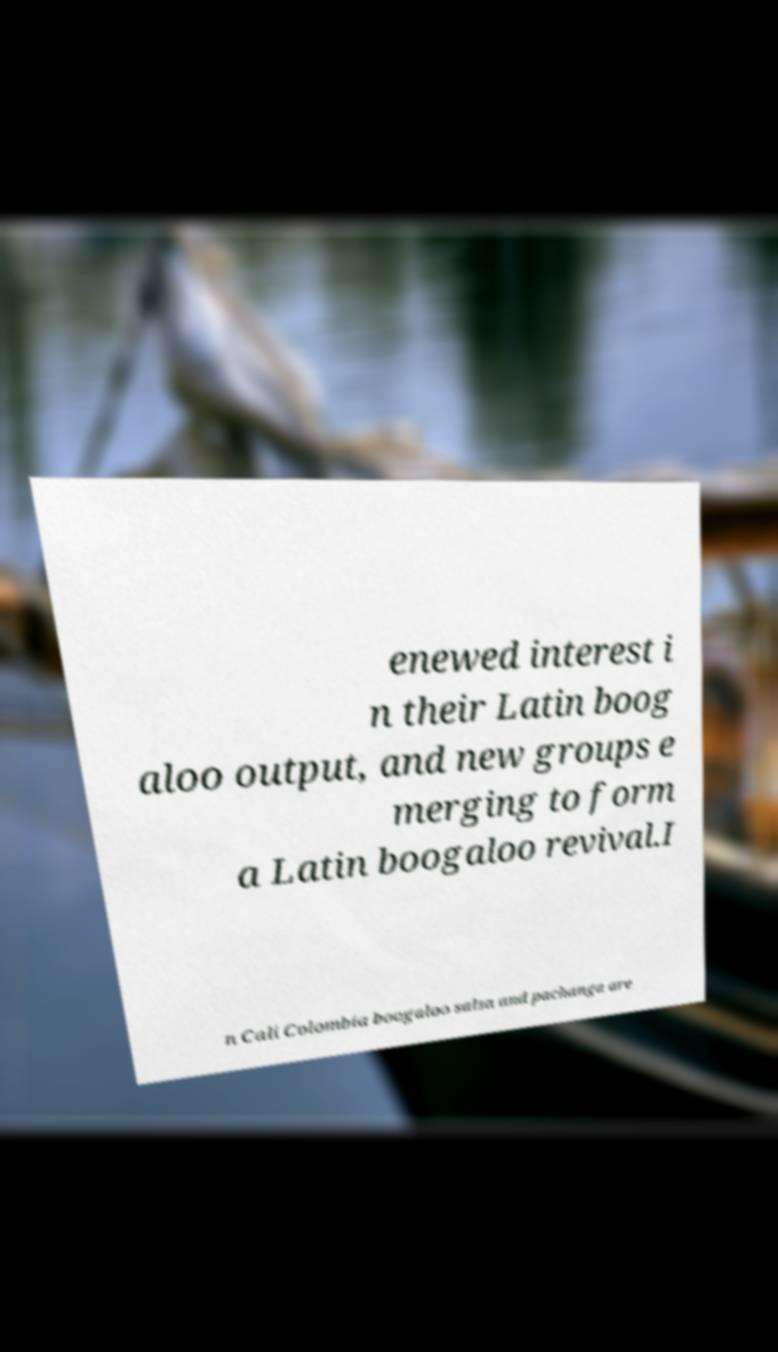Can you accurately transcribe the text from the provided image for me? enewed interest i n their Latin boog aloo output, and new groups e merging to form a Latin boogaloo revival.I n Cali Colombia boogaloo salsa and pachanga are 